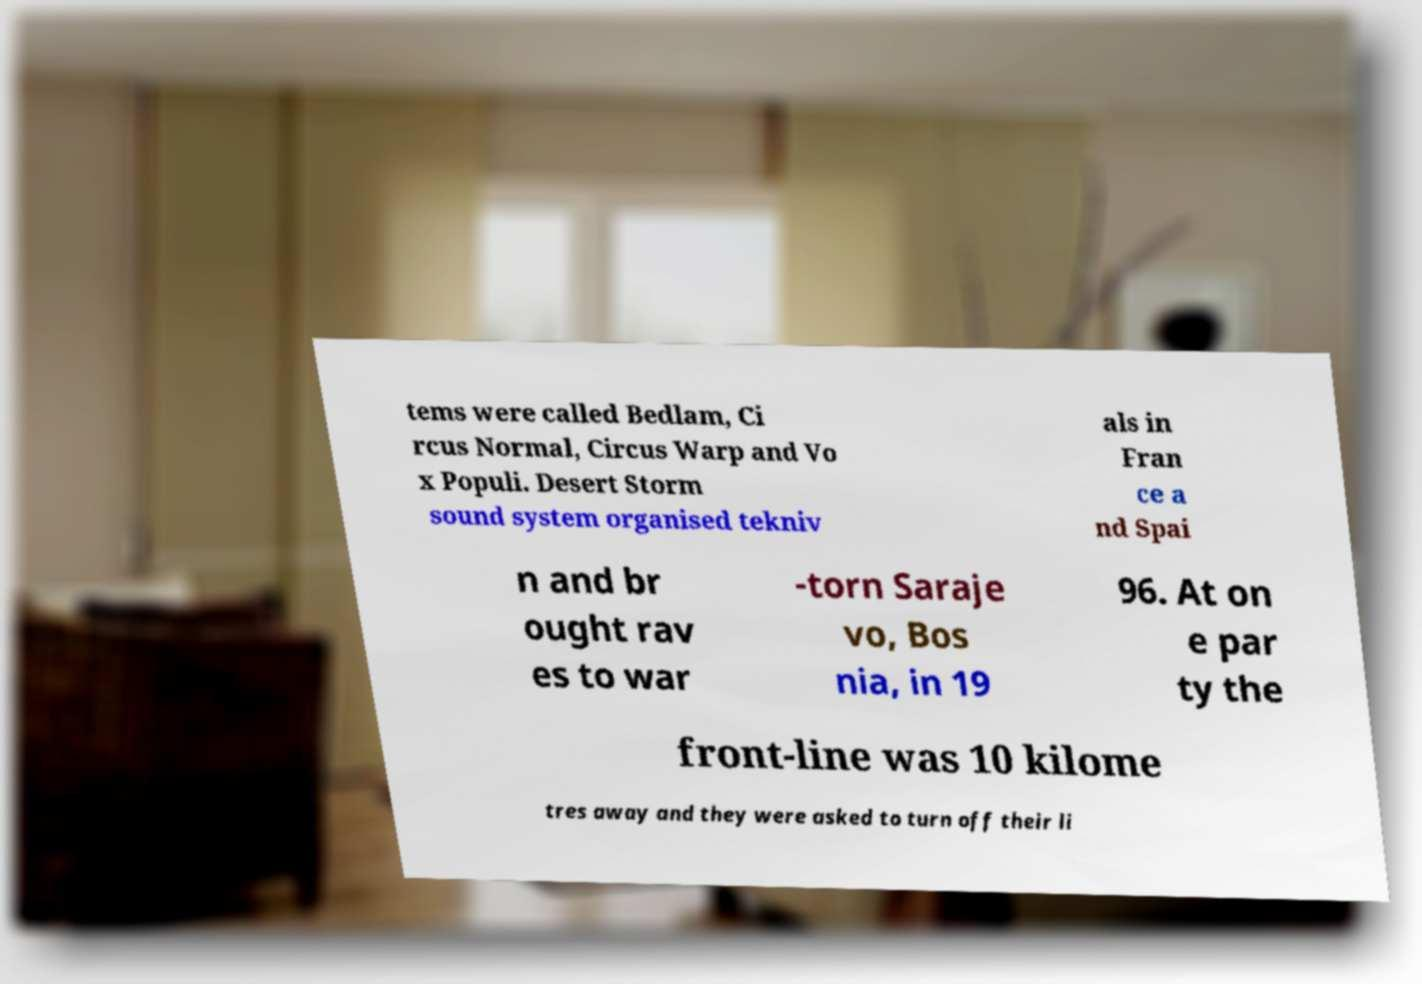Please read and relay the text visible in this image. What does it say? tems were called Bedlam, Ci rcus Normal, Circus Warp and Vo x Populi. Desert Storm sound system organised tekniv als in Fran ce a nd Spai n and br ought rav es to war -torn Saraje vo, Bos nia, in 19 96. At on e par ty the front-line was 10 kilome tres away and they were asked to turn off their li 